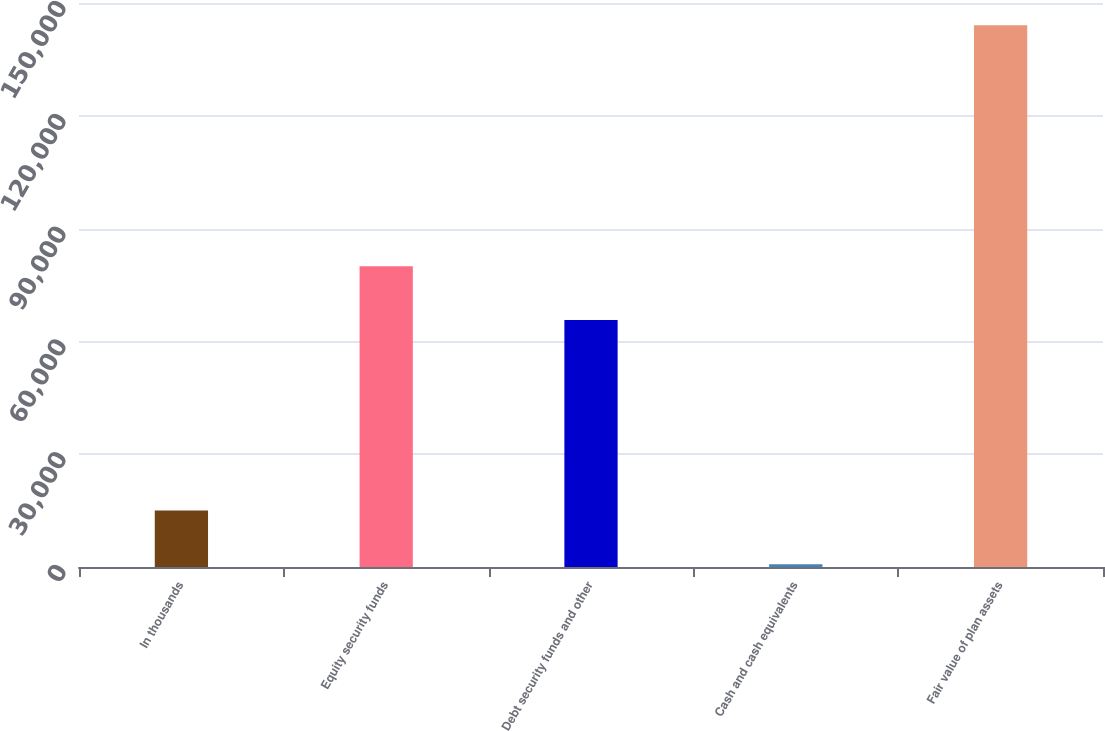Convert chart. <chart><loc_0><loc_0><loc_500><loc_500><bar_chart><fcel>In thousands<fcel>Equity security funds<fcel>Debt security funds and other<fcel>Cash and cash equivalents<fcel>Fair value of plan assets<nl><fcel>15038.9<fcel>80012.9<fcel>65674<fcel>700<fcel>144089<nl></chart> 